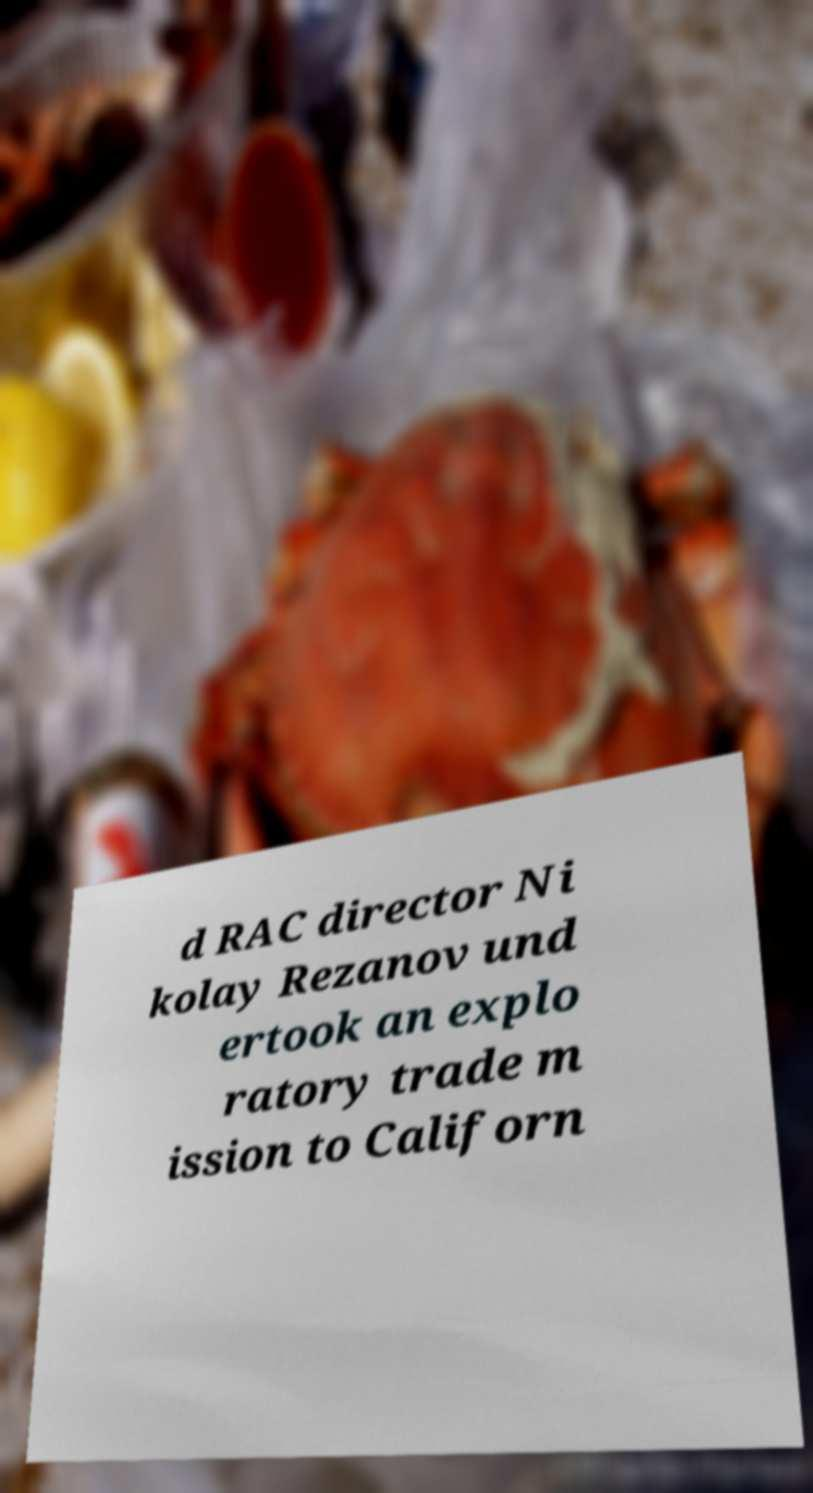Can you read and provide the text displayed in the image?This photo seems to have some interesting text. Can you extract and type it out for me? d RAC director Ni kolay Rezanov und ertook an explo ratory trade m ission to Californ 